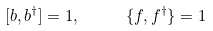<formula> <loc_0><loc_0><loc_500><loc_500>[ b , b ^ { \dagger } ] = 1 , \quad \ \{ f , f ^ { \dagger } \} = 1</formula> 